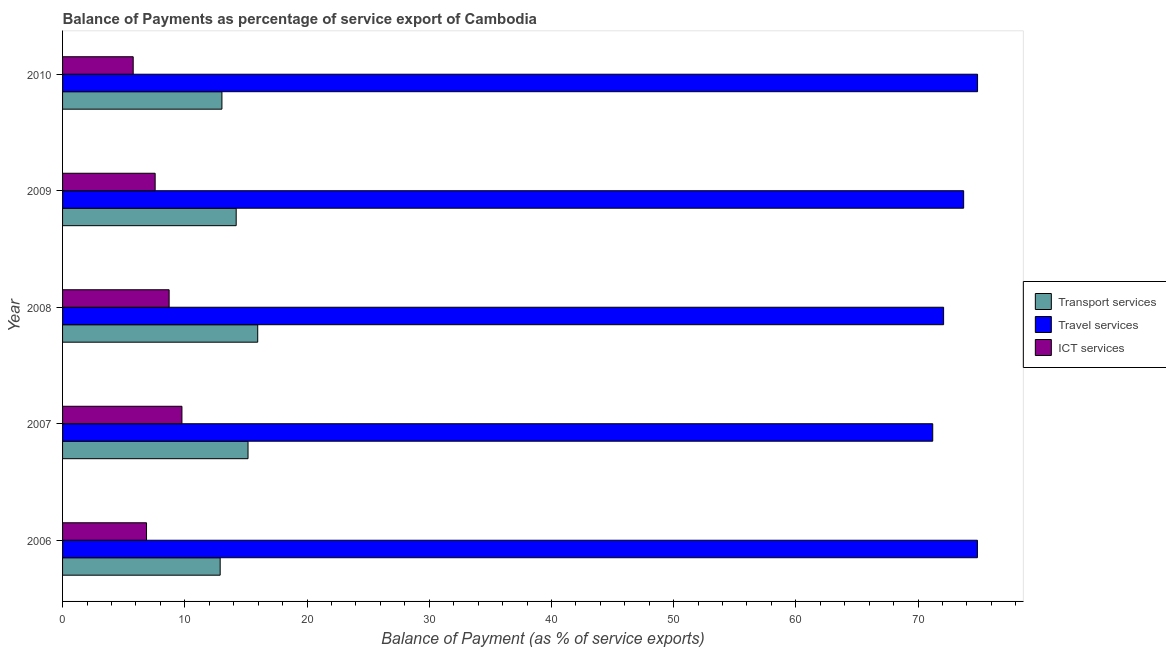How many different coloured bars are there?
Your response must be concise. 3. Are the number of bars per tick equal to the number of legend labels?
Ensure brevity in your answer.  Yes. How many bars are there on the 3rd tick from the top?
Your answer should be compact. 3. How many bars are there on the 4th tick from the bottom?
Your response must be concise. 3. What is the balance of payment of ict services in 2010?
Keep it short and to the point. 5.78. Across all years, what is the maximum balance of payment of transport services?
Your answer should be compact. 15.97. Across all years, what is the minimum balance of payment of ict services?
Keep it short and to the point. 5.78. What is the total balance of payment of ict services in the graph?
Your answer should be very brief. 38.71. What is the difference between the balance of payment of travel services in 2006 and that in 2010?
Give a very brief answer. -0.01. What is the difference between the balance of payment of transport services in 2006 and the balance of payment of ict services in 2009?
Your answer should be compact. 5.32. What is the average balance of payment of transport services per year?
Give a very brief answer. 14.26. In the year 2006, what is the difference between the balance of payment of transport services and balance of payment of ict services?
Give a very brief answer. 6.03. What is the ratio of the balance of payment of ict services in 2009 to that in 2010?
Your response must be concise. 1.31. Is the balance of payment of transport services in 2007 less than that in 2010?
Make the answer very short. No. What is the difference between the highest and the second highest balance of payment of ict services?
Your answer should be compact. 1.05. What is the difference between the highest and the lowest balance of payment of travel services?
Give a very brief answer. 3.67. Is the sum of the balance of payment of travel services in 2008 and 2009 greater than the maximum balance of payment of transport services across all years?
Your answer should be very brief. Yes. What does the 2nd bar from the top in 2009 represents?
Your answer should be very brief. Travel services. What does the 2nd bar from the bottom in 2007 represents?
Your response must be concise. Travel services. How many bars are there?
Your answer should be compact. 15. Are all the bars in the graph horizontal?
Make the answer very short. Yes. Does the graph contain any zero values?
Ensure brevity in your answer.  No. Does the graph contain grids?
Offer a terse response. No. How many legend labels are there?
Keep it short and to the point. 3. How are the legend labels stacked?
Your response must be concise. Vertical. What is the title of the graph?
Offer a terse response. Balance of Payments as percentage of service export of Cambodia. Does "Domestic economy" appear as one of the legend labels in the graph?
Ensure brevity in your answer.  No. What is the label or title of the X-axis?
Your response must be concise. Balance of Payment (as % of service exports). What is the Balance of Payment (as % of service exports) of Transport services in 2006?
Offer a terse response. 12.89. What is the Balance of Payment (as % of service exports) in Travel services in 2006?
Your response must be concise. 74.85. What is the Balance of Payment (as % of service exports) in ICT services in 2006?
Make the answer very short. 6.87. What is the Balance of Payment (as % of service exports) in Transport services in 2007?
Your answer should be very brief. 15.17. What is the Balance of Payment (as % of service exports) of Travel services in 2007?
Keep it short and to the point. 71.2. What is the Balance of Payment (as % of service exports) of ICT services in 2007?
Your answer should be compact. 9.77. What is the Balance of Payment (as % of service exports) in Transport services in 2008?
Give a very brief answer. 15.97. What is the Balance of Payment (as % of service exports) of Travel services in 2008?
Keep it short and to the point. 72.09. What is the Balance of Payment (as % of service exports) of ICT services in 2008?
Your answer should be very brief. 8.72. What is the Balance of Payment (as % of service exports) in Transport services in 2009?
Offer a very short reply. 14.21. What is the Balance of Payment (as % of service exports) of Travel services in 2009?
Offer a terse response. 73.73. What is the Balance of Payment (as % of service exports) in ICT services in 2009?
Your answer should be compact. 7.58. What is the Balance of Payment (as % of service exports) in Transport services in 2010?
Your answer should be compact. 13.04. What is the Balance of Payment (as % of service exports) of Travel services in 2010?
Provide a short and direct response. 74.87. What is the Balance of Payment (as % of service exports) in ICT services in 2010?
Offer a very short reply. 5.78. Across all years, what is the maximum Balance of Payment (as % of service exports) in Transport services?
Ensure brevity in your answer.  15.97. Across all years, what is the maximum Balance of Payment (as % of service exports) in Travel services?
Keep it short and to the point. 74.87. Across all years, what is the maximum Balance of Payment (as % of service exports) in ICT services?
Offer a very short reply. 9.77. Across all years, what is the minimum Balance of Payment (as % of service exports) of Transport services?
Provide a short and direct response. 12.89. Across all years, what is the minimum Balance of Payment (as % of service exports) of Travel services?
Make the answer very short. 71.2. Across all years, what is the minimum Balance of Payment (as % of service exports) of ICT services?
Offer a terse response. 5.78. What is the total Balance of Payment (as % of service exports) of Transport services in the graph?
Ensure brevity in your answer.  71.28. What is the total Balance of Payment (as % of service exports) of Travel services in the graph?
Your answer should be very brief. 366.73. What is the total Balance of Payment (as % of service exports) in ICT services in the graph?
Give a very brief answer. 38.71. What is the difference between the Balance of Payment (as % of service exports) in Transport services in 2006 and that in 2007?
Your response must be concise. -2.28. What is the difference between the Balance of Payment (as % of service exports) in Travel services in 2006 and that in 2007?
Ensure brevity in your answer.  3.66. What is the difference between the Balance of Payment (as % of service exports) in ICT services in 2006 and that in 2007?
Provide a short and direct response. -2.9. What is the difference between the Balance of Payment (as % of service exports) of Transport services in 2006 and that in 2008?
Provide a short and direct response. -3.07. What is the difference between the Balance of Payment (as % of service exports) of Travel services in 2006 and that in 2008?
Offer a very short reply. 2.77. What is the difference between the Balance of Payment (as % of service exports) in ICT services in 2006 and that in 2008?
Make the answer very short. -1.85. What is the difference between the Balance of Payment (as % of service exports) in Transport services in 2006 and that in 2009?
Provide a short and direct response. -1.31. What is the difference between the Balance of Payment (as % of service exports) in Travel services in 2006 and that in 2009?
Offer a very short reply. 1.13. What is the difference between the Balance of Payment (as % of service exports) in ICT services in 2006 and that in 2009?
Keep it short and to the point. -0.71. What is the difference between the Balance of Payment (as % of service exports) of Transport services in 2006 and that in 2010?
Make the answer very short. -0.14. What is the difference between the Balance of Payment (as % of service exports) in Travel services in 2006 and that in 2010?
Keep it short and to the point. -0.01. What is the difference between the Balance of Payment (as % of service exports) in ICT services in 2006 and that in 2010?
Your answer should be very brief. 1.09. What is the difference between the Balance of Payment (as % of service exports) of Transport services in 2007 and that in 2008?
Your answer should be very brief. -0.79. What is the difference between the Balance of Payment (as % of service exports) in Travel services in 2007 and that in 2008?
Ensure brevity in your answer.  -0.89. What is the difference between the Balance of Payment (as % of service exports) in ICT services in 2007 and that in 2008?
Keep it short and to the point. 1.05. What is the difference between the Balance of Payment (as % of service exports) in Transport services in 2007 and that in 2009?
Make the answer very short. 0.97. What is the difference between the Balance of Payment (as % of service exports) in Travel services in 2007 and that in 2009?
Make the answer very short. -2.53. What is the difference between the Balance of Payment (as % of service exports) of ICT services in 2007 and that in 2009?
Provide a succinct answer. 2.19. What is the difference between the Balance of Payment (as % of service exports) in Transport services in 2007 and that in 2010?
Your response must be concise. 2.14. What is the difference between the Balance of Payment (as % of service exports) in Travel services in 2007 and that in 2010?
Keep it short and to the point. -3.67. What is the difference between the Balance of Payment (as % of service exports) of ICT services in 2007 and that in 2010?
Your answer should be very brief. 3.99. What is the difference between the Balance of Payment (as % of service exports) of Transport services in 2008 and that in 2009?
Ensure brevity in your answer.  1.76. What is the difference between the Balance of Payment (as % of service exports) in Travel services in 2008 and that in 2009?
Offer a very short reply. -1.64. What is the difference between the Balance of Payment (as % of service exports) in ICT services in 2008 and that in 2009?
Make the answer very short. 1.14. What is the difference between the Balance of Payment (as % of service exports) of Transport services in 2008 and that in 2010?
Provide a succinct answer. 2.93. What is the difference between the Balance of Payment (as % of service exports) in Travel services in 2008 and that in 2010?
Your answer should be compact. -2.78. What is the difference between the Balance of Payment (as % of service exports) of ICT services in 2008 and that in 2010?
Give a very brief answer. 2.94. What is the difference between the Balance of Payment (as % of service exports) in Transport services in 2009 and that in 2010?
Keep it short and to the point. 1.17. What is the difference between the Balance of Payment (as % of service exports) of Travel services in 2009 and that in 2010?
Your answer should be compact. -1.14. What is the difference between the Balance of Payment (as % of service exports) of ICT services in 2009 and that in 2010?
Your answer should be compact. 1.8. What is the difference between the Balance of Payment (as % of service exports) in Transport services in 2006 and the Balance of Payment (as % of service exports) in Travel services in 2007?
Give a very brief answer. -58.3. What is the difference between the Balance of Payment (as % of service exports) in Transport services in 2006 and the Balance of Payment (as % of service exports) in ICT services in 2007?
Give a very brief answer. 3.13. What is the difference between the Balance of Payment (as % of service exports) of Travel services in 2006 and the Balance of Payment (as % of service exports) of ICT services in 2007?
Keep it short and to the point. 65.09. What is the difference between the Balance of Payment (as % of service exports) in Transport services in 2006 and the Balance of Payment (as % of service exports) in Travel services in 2008?
Make the answer very short. -59.19. What is the difference between the Balance of Payment (as % of service exports) in Transport services in 2006 and the Balance of Payment (as % of service exports) in ICT services in 2008?
Your response must be concise. 4.18. What is the difference between the Balance of Payment (as % of service exports) in Travel services in 2006 and the Balance of Payment (as % of service exports) in ICT services in 2008?
Your response must be concise. 66.14. What is the difference between the Balance of Payment (as % of service exports) of Transport services in 2006 and the Balance of Payment (as % of service exports) of Travel services in 2009?
Give a very brief answer. -60.83. What is the difference between the Balance of Payment (as % of service exports) of Transport services in 2006 and the Balance of Payment (as % of service exports) of ICT services in 2009?
Provide a succinct answer. 5.32. What is the difference between the Balance of Payment (as % of service exports) of Travel services in 2006 and the Balance of Payment (as % of service exports) of ICT services in 2009?
Offer a terse response. 67.28. What is the difference between the Balance of Payment (as % of service exports) in Transport services in 2006 and the Balance of Payment (as % of service exports) in Travel services in 2010?
Your answer should be very brief. -61.97. What is the difference between the Balance of Payment (as % of service exports) in Transport services in 2006 and the Balance of Payment (as % of service exports) in ICT services in 2010?
Make the answer very short. 7.12. What is the difference between the Balance of Payment (as % of service exports) in Travel services in 2006 and the Balance of Payment (as % of service exports) in ICT services in 2010?
Provide a short and direct response. 69.07. What is the difference between the Balance of Payment (as % of service exports) in Transport services in 2007 and the Balance of Payment (as % of service exports) in Travel services in 2008?
Keep it short and to the point. -56.91. What is the difference between the Balance of Payment (as % of service exports) of Transport services in 2007 and the Balance of Payment (as % of service exports) of ICT services in 2008?
Your answer should be compact. 6.46. What is the difference between the Balance of Payment (as % of service exports) of Travel services in 2007 and the Balance of Payment (as % of service exports) of ICT services in 2008?
Make the answer very short. 62.48. What is the difference between the Balance of Payment (as % of service exports) in Transport services in 2007 and the Balance of Payment (as % of service exports) in Travel services in 2009?
Keep it short and to the point. -58.55. What is the difference between the Balance of Payment (as % of service exports) of Transport services in 2007 and the Balance of Payment (as % of service exports) of ICT services in 2009?
Your answer should be very brief. 7.6. What is the difference between the Balance of Payment (as % of service exports) in Travel services in 2007 and the Balance of Payment (as % of service exports) in ICT services in 2009?
Ensure brevity in your answer.  63.62. What is the difference between the Balance of Payment (as % of service exports) in Transport services in 2007 and the Balance of Payment (as % of service exports) in Travel services in 2010?
Offer a very short reply. -59.69. What is the difference between the Balance of Payment (as % of service exports) in Transport services in 2007 and the Balance of Payment (as % of service exports) in ICT services in 2010?
Your answer should be compact. 9.39. What is the difference between the Balance of Payment (as % of service exports) in Travel services in 2007 and the Balance of Payment (as % of service exports) in ICT services in 2010?
Your answer should be compact. 65.42. What is the difference between the Balance of Payment (as % of service exports) in Transport services in 2008 and the Balance of Payment (as % of service exports) in Travel services in 2009?
Provide a succinct answer. -57.76. What is the difference between the Balance of Payment (as % of service exports) in Transport services in 2008 and the Balance of Payment (as % of service exports) in ICT services in 2009?
Provide a short and direct response. 8.39. What is the difference between the Balance of Payment (as % of service exports) in Travel services in 2008 and the Balance of Payment (as % of service exports) in ICT services in 2009?
Provide a short and direct response. 64.51. What is the difference between the Balance of Payment (as % of service exports) of Transport services in 2008 and the Balance of Payment (as % of service exports) of Travel services in 2010?
Your answer should be very brief. -58.9. What is the difference between the Balance of Payment (as % of service exports) in Transport services in 2008 and the Balance of Payment (as % of service exports) in ICT services in 2010?
Ensure brevity in your answer.  10.19. What is the difference between the Balance of Payment (as % of service exports) of Travel services in 2008 and the Balance of Payment (as % of service exports) of ICT services in 2010?
Your response must be concise. 66.31. What is the difference between the Balance of Payment (as % of service exports) in Transport services in 2009 and the Balance of Payment (as % of service exports) in Travel services in 2010?
Your answer should be very brief. -60.66. What is the difference between the Balance of Payment (as % of service exports) of Transport services in 2009 and the Balance of Payment (as % of service exports) of ICT services in 2010?
Your response must be concise. 8.43. What is the difference between the Balance of Payment (as % of service exports) in Travel services in 2009 and the Balance of Payment (as % of service exports) in ICT services in 2010?
Keep it short and to the point. 67.95. What is the average Balance of Payment (as % of service exports) in Transport services per year?
Your answer should be very brief. 14.26. What is the average Balance of Payment (as % of service exports) of Travel services per year?
Provide a short and direct response. 73.35. What is the average Balance of Payment (as % of service exports) of ICT services per year?
Provide a short and direct response. 7.74. In the year 2006, what is the difference between the Balance of Payment (as % of service exports) of Transport services and Balance of Payment (as % of service exports) of Travel services?
Provide a succinct answer. -61.96. In the year 2006, what is the difference between the Balance of Payment (as % of service exports) in Transport services and Balance of Payment (as % of service exports) in ICT services?
Offer a very short reply. 6.02. In the year 2006, what is the difference between the Balance of Payment (as % of service exports) of Travel services and Balance of Payment (as % of service exports) of ICT services?
Make the answer very short. 67.98. In the year 2007, what is the difference between the Balance of Payment (as % of service exports) of Transport services and Balance of Payment (as % of service exports) of Travel services?
Provide a succinct answer. -56.02. In the year 2007, what is the difference between the Balance of Payment (as % of service exports) in Transport services and Balance of Payment (as % of service exports) in ICT services?
Offer a very short reply. 5.41. In the year 2007, what is the difference between the Balance of Payment (as % of service exports) of Travel services and Balance of Payment (as % of service exports) of ICT services?
Give a very brief answer. 61.43. In the year 2008, what is the difference between the Balance of Payment (as % of service exports) in Transport services and Balance of Payment (as % of service exports) in Travel services?
Give a very brief answer. -56.12. In the year 2008, what is the difference between the Balance of Payment (as % of service exports) of Transport services and Balance of Payment (as % of service exports) of ICT services?
Offer a very short reply. 7.25. In the year 2008, what is the difference between the Balance of Payment (as % of service exports) of Travel services and Balance of Payment (as % of service exports) of ICT services?
Provide a short and direct response. 63.37. In the year 2009, what is the difference between the Balance of Payment (as % of service exports) of Transport services and Balance of Payment (as % of service exports) of Travel services?
Give a very brief answer. -59.52. In the year 2009, what is the difference between the Balance of Payment (as % of service exports) in Transport services and Balance of Payment (as % of service exports) in ICT services?
Give a very brief answer. 6.63. In the year 2009, what is the difference between the Balance of Payment (as % of service exports) of Travel services and Balance of Payment (as % of service exports) of ICT services?
Your response must be concise. 66.15. In the year 2010, what is the difference between the Balance of Payment (as % of service exports) of Transport services and Balance of Payment (as % of service exports) of Travel services?
Offer a very short reply. -61.83. In the year 2010, what is the difference between the Balance of Payment (as % of service exports) in Transport services and Balance of Payment (as % of service exports) in ICT services?
Offer a very short reply. 7.26. In the year 2010, what is the difference between the Balance of Payment (as % of service exports) of Travel services and Balance of Payment (as % of service exports) of ICT services?
Keep it short and to the point. 69.09. What is the ratio of the Balance of Payment (as % of service exports) in Transport services in 2006 to that in 2007?
Keep it short and to the point. 0.85. What is the ratio of the Balance of Payment (as % of service exports) in Travel services in 2006 to that in 2007?
Provide a short and direct response. 1.05. What is the ratio of the Balance of Payment (as % of service exports) of ICT services in 2006 to that in 2007?
Ensure brevity in your answer.  0.7. What is the ratio of the Balance of Payment (as % of service exports) of Transport services in 2006 to that in 2008?
Keep it short and to the point. 0.81. What is the ratio of the Balance of Payment (as % of service exports) of Travel services in 2006 to that in 2008?
Give a very brief answer. 1.04. What is the ratio of the Balance of Payment (as % of service exports) in ICT services in 2006 to that in 2008?
Keep it short and to the point. 0.79. What is the ratio of the Balance of Payment (as % of service exports) of Transport services in 2006 to that in 2009?
Your response must be concise. 0.91. What is the ratio of the Balance of Payment (as % of service exports) in Travel services in 2006 to that in 2009?
Keep it short and to the point. 1.02. What is the ratio of the Balance of Payment (as % of service exports) of ICT services in 2006 to that in 2009?
Provide a succinct answer. 0.91. What is the ratio of the Balance of Payment (as % of service exports) in Transport services in 2006 to that in 2010?
Keep it short and to the point. 0.99. What is the ratio of the Balance of Payment (as % of service exports) of ICT services in 2006 to that in 2010?
Offer a very short reply. 1.19. What is the ratio of the Balance of Payment (as % of service exports) of Transport services in 2007 to that in 2008?
Make the answer very short. 0.95. What is the ratio of the Balance of Payment (as % of service exports) of ICT services in 2007 to that in 2008?
Provide a short and direct response. 1.12. What is the ratio of the Balance of Payment (as % of service exports) of Transport services in 2007 to that in 2009?
Provide a succinct answer. 1.07. What is the ratio of the Balance of Payment (as % of service exports) of Travel services in 2007 to that in 2009?
Provide a succinct answer. 0.97. What is the ratio of the Balance of Payment (as % of service exports) of ICT services in 2007 to that in 2009?
Offer a terse response. 1.29. What is the ratio of the Balance of Payment (as % of service exports) of Transport services in 2007 to that in 2010?
Ensure brevity in your answer.  1.16. What is the ratio of the Balance of Payment (as % of service exports) in Travel services in 2007 to that in 2010?
Your answer should be very brief. 0.95. What is the ratio of the Balance of Payment (as % of service exports) in ICT services in 2007 to that in 2010?
Provide a short and direct response. 1.69. What is the ratio of the Balance of Payment (as % of service exports) in Transport services in 2008 to that in 2009?
Keep it short and to the point. 1.12. What is the ratio of the Balance of Payment (as % of service exports) in Travel services in 2008 to that in 2009?
Make the answer very short. 0.98. What is the ratio of the Balance of Payment (as % of service exports) in ICT services in 2008 to that in 2009?
Ensure brevity in your answer.  1.15. What is the ratio of the Balance of Payment (as % of service exports) in Transport services in 2008 to that in 2010?
Provide a short and direct response. 1.22. What is the ratio of the Balance of Payment (as % of service exports) in Travel services in 2008 to that in 2010?
Offer a very short reply. 0.96. What is the ratio of the Balance of Payment (as % of service exports) in ICT services in 2008 to that in 2010?
Provide a succinct answer. 1.51. What is the ratio of the Balance of Payment (as % of service exports) of Transport services in 2009 to that in 2010?
Give a very brief answer. 1.09. What is the ratio of the Balance of Payment (as % of service exports) in ICT services in 2009 to that in 2010?
Make the answer very short. 1.31. What is the difference between the highest and the second highest Balance of Payment (as % of service exports) in Transport services?
Provide a succinct answer. 0.79. What is the difference between the highest and the second highest Balance of Payment (as % of service exports) in Travel services?
Ensure brevity in your answer.  0.01. What is the difference between the highest and the second highest Balance of Payment (as % of service exports) of ICT services?
Your answer should be very brief. 1.05. What is the difference between the highest and the lowest Balance of Payment (as % of service exports) of Transport services?
Keep it short and to the point. 3.07. What is the difference between the highest and the lowest Balance of Payment (as % of service exports) of Travel services?
Provide a short and direct response. 3.67. What is the difference between the highest and the lowest Balance of Payment (as % of service exports) of ICT services?
Provide a succinct answer. 3.99. 